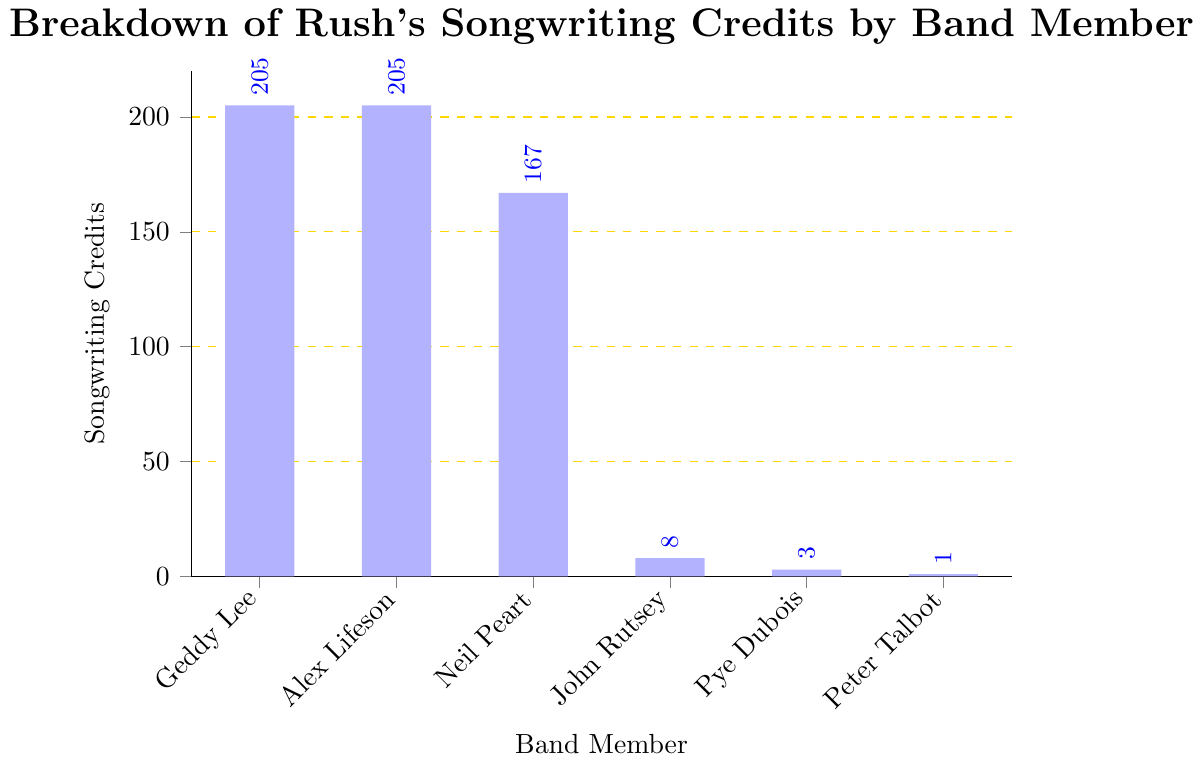Which band member has the highest number of songwriting credits? By looking at the chart, Geddy Lee and Alex Lifeson have the same highest number of songwriting credits, each with 205.
Answer: Geddy Lee and Alex Lifeson What is the total number of songwriting credits for the three main members, Geddy Lee, Alex Lifeson, and Neil Peart? Sum the credits of Geddy Lee (205), Alex Lifeson (205), and Neil Peart (167) to get the total: 205 + 205 + 167 = 577.
Answer: 577 How many more songwriting credits does Neil Peart have compared to John Rutsey? Subtract the number of credits of John Rutsey (8) from Neil Peart's credits (167): 167 - 8 = 159.
Answer: 159 What is the average number of songwriting credits for the external contributors (John Rutsey, Pye Dubois, and Peter Talbot)? Sum the credits of John Rutsey (8), Pye Dubois (3), and Peter Talbot (1) to get 8 + 3 + 1 = 12, then divide by 3: 12 / 3 = 4.
Answer: 4 Which band member has the least number of songwriting credits, and how many do they have? By looking at the chart, Peter Talbot has the least number of songwriting credits with 1.
Answer: Peter Talbot, 1 How much taller is the bar representing songwriting credits for Geddy Lee compared to Peter Talbot? Subtract the number of credits of Peter Talbot (1) from Geddy Lee's credits (205): 205 - 1 = 204.
Answer: 204 If you combine the songwriting credits of Neil Peart, John Rutsey, Pye Dubois, and Peter Talbot, what is the total? Sum the credits of Neil Peart (167), John Rutsey (8), Pye Dubois (3), and Peter Talbot (1): 167 + 8 + 3 + 1 = 179.
Answer: 179 Who are the band members that have credited at least 200 songs? By looking at the chart, Geddy Lee and Alex Lifeson each have 205 songwriting credits.
Answer: Geddy Lee and Alex Lifeson 